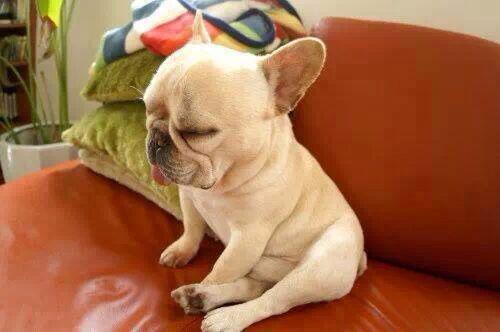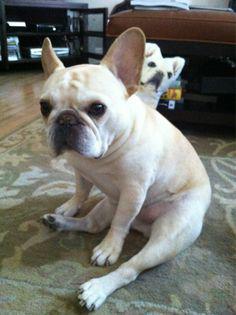The first image is the image on the left, the second image is the image on the right. For the images displayed, is the sentence "One dog is indoors, and another is outdoors." factually correct? Answer yes or no. No. The first image is the image on the left, the second image is the image on the right. Evaluate the accuracy of this statement regarding the images: "An image shows a whitish dog sitting with hind legs sticking forward on a carpet indoors.". Is it true? Answer yes or no. Yes. 